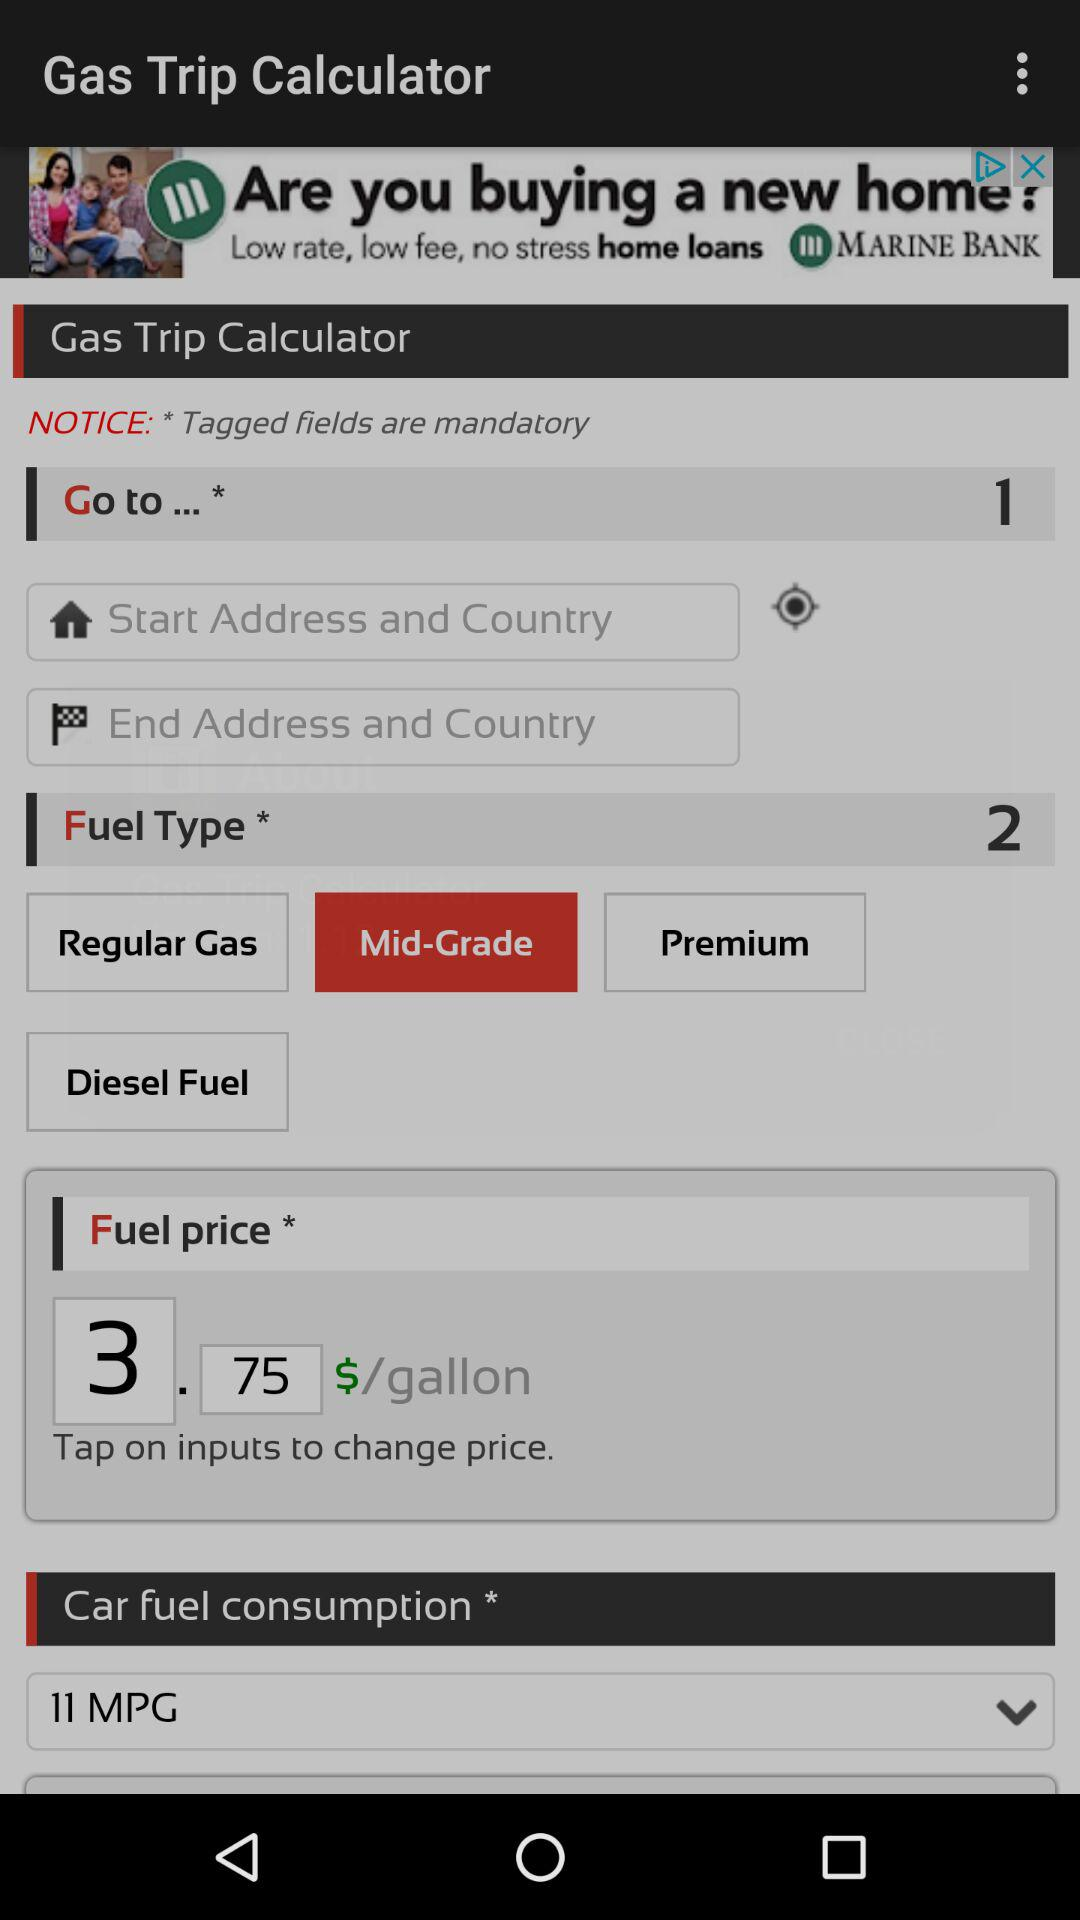What is the fuel price per gallon? The fuel price per gallon is $3.75. 